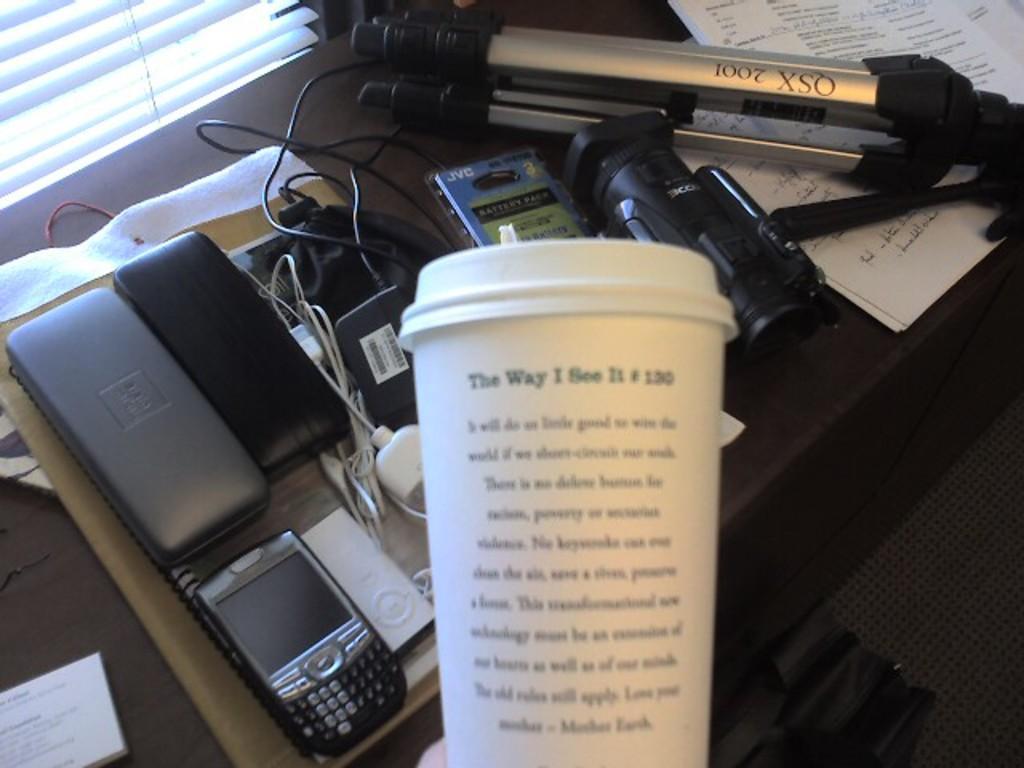Describe this image in one or two sentences. This is table. On the table there is a camera, papers, mobile, cables, and devices. This is bag and there is a carpet on the floor. 